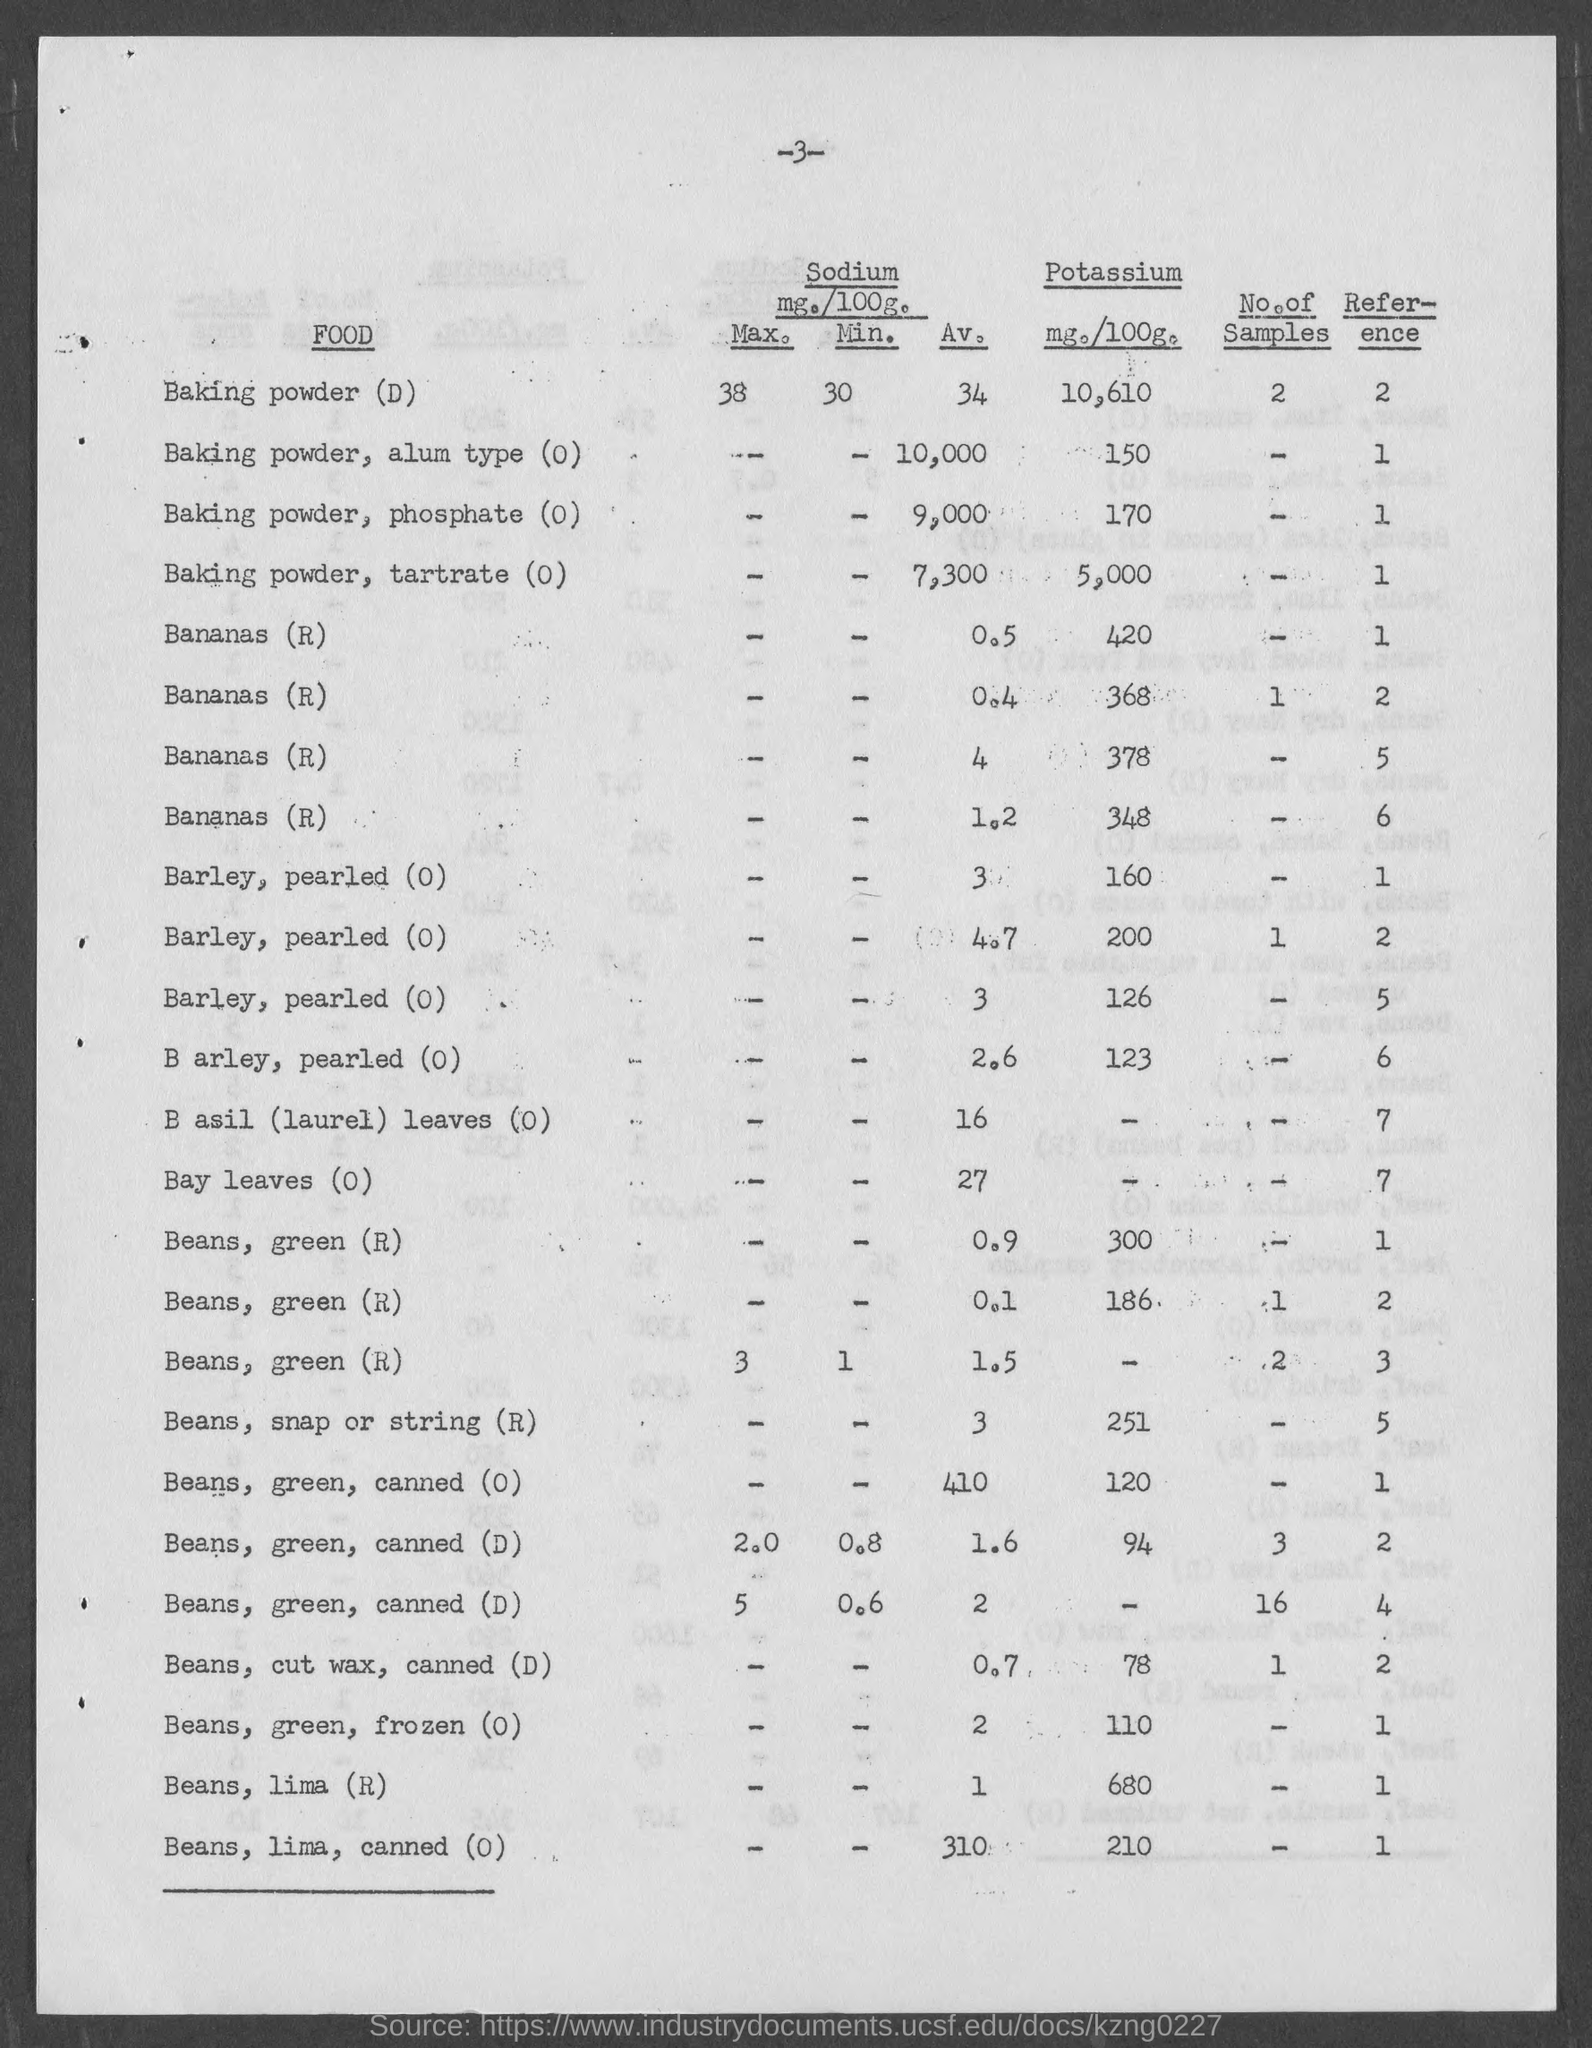Give some essential details in this illustration. The amount of potassium in 100 grams of lima beans is 680 milligrams. The amount of potassium in baking powder, tartrate (O) is 5,000 milligrams per 100 grams. The amount of potassium in 100 grams of Beans, cut wax, canned (D) is 78 milligrams. The amount of potassium (mg./100g) in baking powder, alum type (O) is 150. I am inquiring about the number located at the top of the current page, specifically the number 3. 